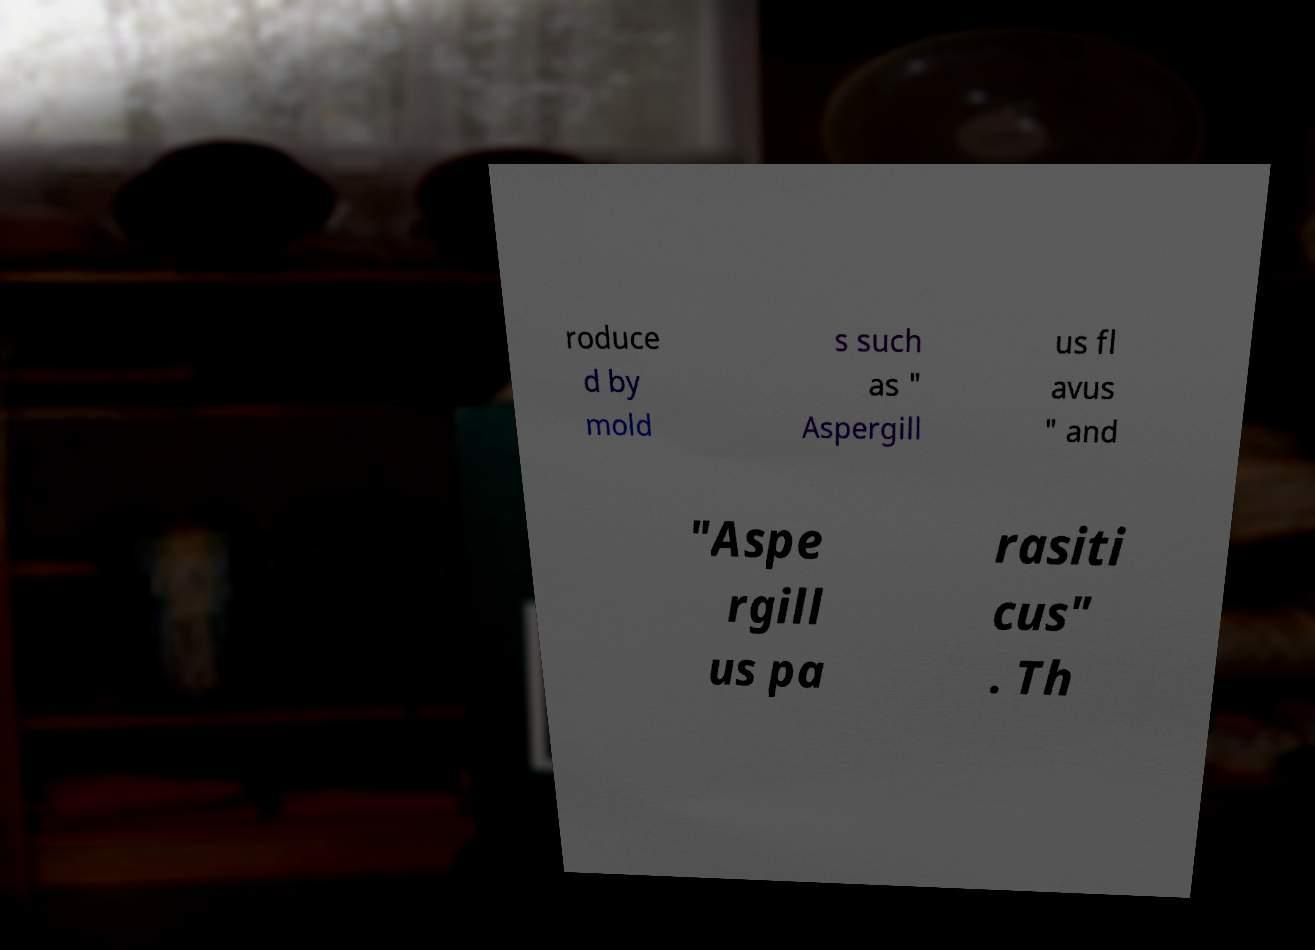Could you assist in decoding the text presented in this image and type it out clearly? roduce d by mold s such as " Aspergill us fl avus " and "Aspe rgill us pa rasiti cus" . Th 